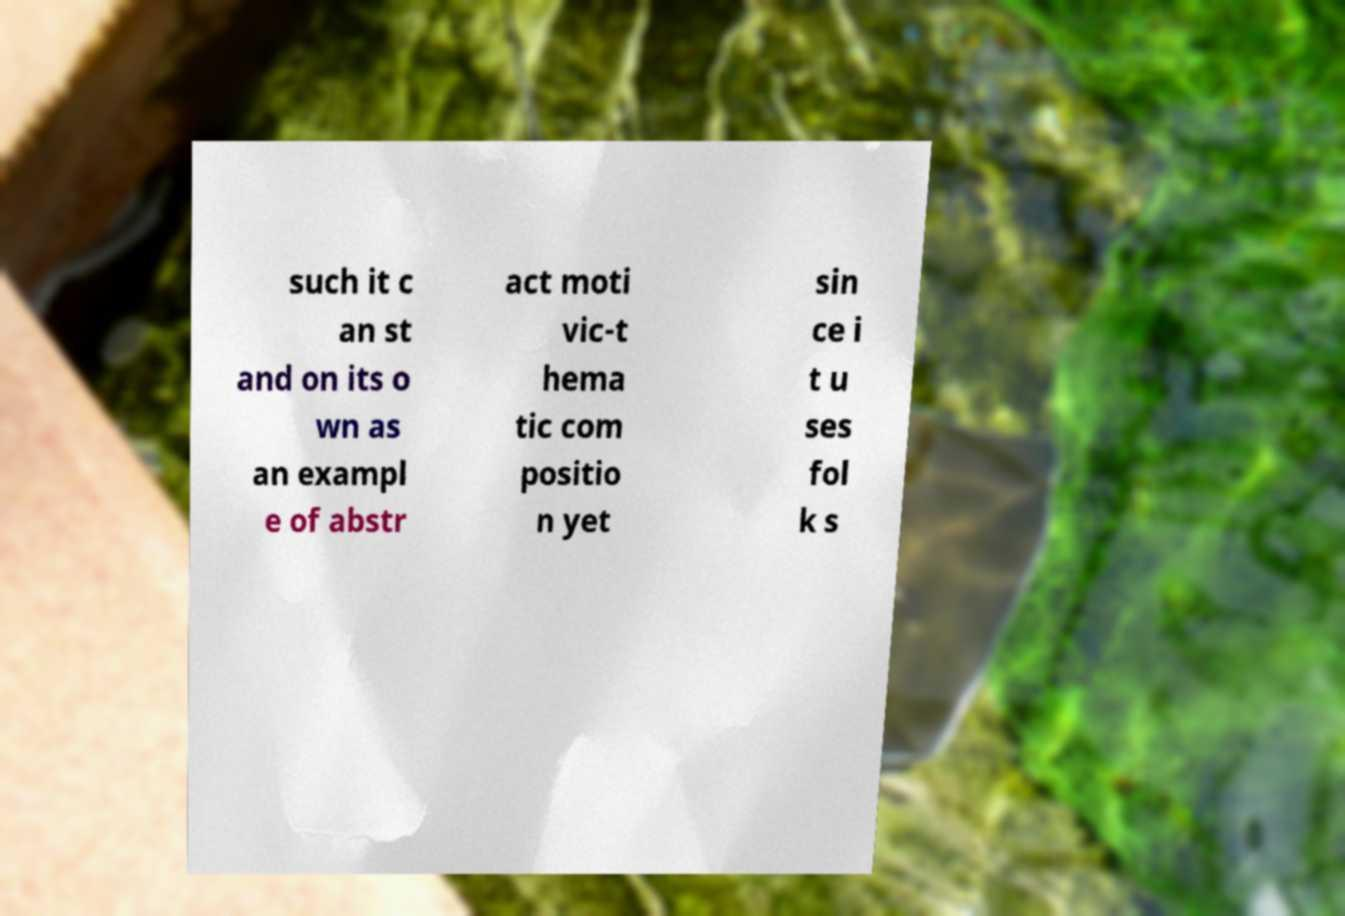Could you assist in decoding the text presented in this image and type it out clearly? such it c an st and on its o wn as an exampl e of abstr act moti vic-t hema tic com positio n yet sin ce i t u ses fol k s 